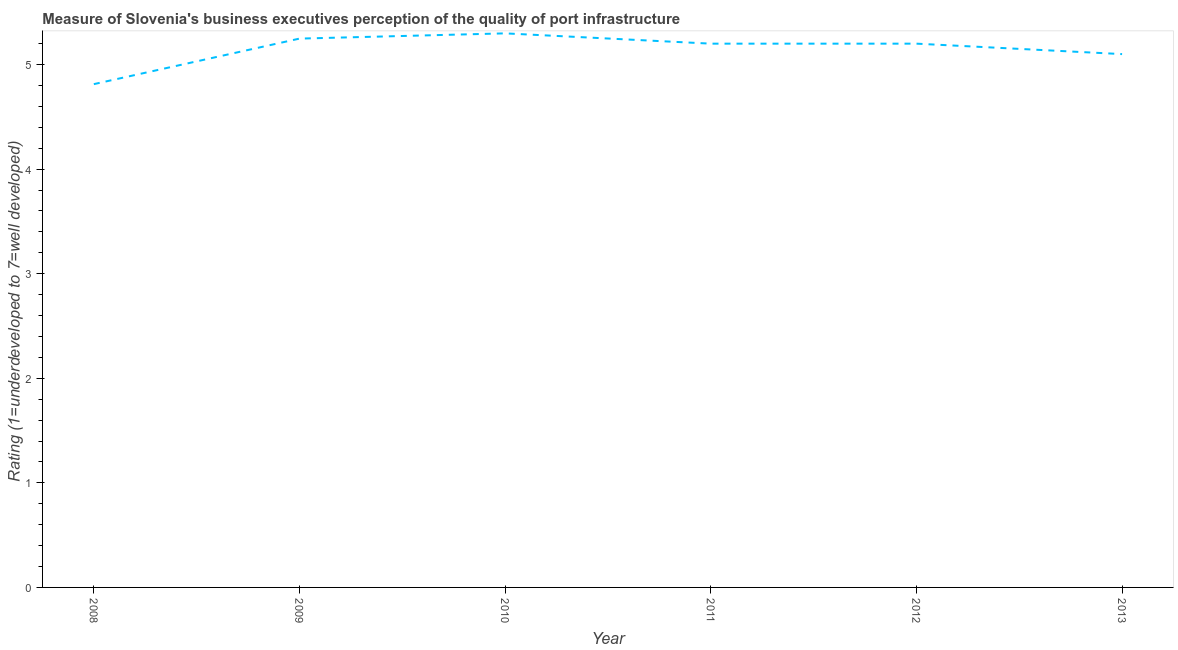What is the rating measuring quality of port infrastructure in 2009?
Give a very brief answer. 5.25. Across all years, what is the maximum rating measuring quality of port infrastructure?
Offer a very short reply. 5.3. Across all years, what is the minimum rating measuring quality of port infrastructure?
Your answer should be compact. 4.81. In which year was the rating measuring quality of port infrastructure maximum?
Your answer should be very brief. 2010. What is the sum of the rating measuring quality of port infrastructure?
Provide a short and direct response. 30.86. What is the difference between the rating measuring quality of port infrastructure in 2008 and 2013?
Ensure brevity in your answer.  -0.29. What is the average rating measuring quality of port infrastructure per year?
Your answer should be very brief. 5.14. What is the median rating measuring quality of port infrastructure?
Provide a short and direct response. 5.2. Do a majority of the years between 2009 and 2008 (inclusive) have rating measuring quality of port infrastructure greater than 2.4 ?
Provide a succinct answer. No. What is the ratio of the rating measuring quality of port infrastructure in 2009 to that in 2013?
Your answer should be compact. 1.03. Is the rating measuring quality of port infrastructure in 2012 less than that in 2013?
Your answer should be very brief. No. What is the difference between the highest and the second highest rating measuring quality of port infrastructure?
Keep it short and to the point. 0.05. Is the sum of the rating measuring quality of port infrastructure in 2010 and 2011 greater than the maximum rating measuring quality of port infrastructure across all years?
Keep it short and to the point. Yes. What is the difference between the highest and the lowest rating measuring quality of port infrastructure?
Provide a succinct answer. 0.49. How many lines are there?
Offer a terse response. 1. What is the difference between two consecutive major ticks on the Y-axis?
Your answer should be compact. 1. Are the values on the major ticks of Y-axis written in scientific E-notation?
Keep it short and to the point. No. Does the graph contain any zero values?
Give a very brief answer. No. Does the graph contain grids?
Provide a short and direct response. No. What is the title of the graph?
Make the answer very short. Measure of Slovenia's business executives perception of the quality of port infrastructure. What is the label or title of the Y-axis?
Offer a very short reply. Rating (1=underdeveloped to 7=well developed) . What is the Rating (1=underdeveloped to 7=well developed)  of 2008?
Provide a short and direct response. 4.81. What is the Rating (1=underdeveloped to 7=well developed)  of 2009?
Keep it short and to the point. 5.25. What is the Rating (1=underdeveloped to 7=well developed)  of 2010?
Ensure brevity in your answer.  5.3. What is the Rating (1=underdeveloped to 7=well developed)  in 2012?
Provide a short and direct response. 5.2. What is the Rating (1=underdeveloped to 7=well developed)  in 2013?
Keep it short and to the point. 5.1. What is the difference between the Rating (1=underdeveloped to 7=well developed)  in 2008 and 2009?
Keep it short and to the point. -0.44. What is the difference between the Rating (1=underdeveloped to 7=well developed)  in 2008 and 2010?
Ensure brevity in your answer.  -0.49. What is the difference between the Rating (1=underdeveloped to 7=well developed)  in 2008 and 2011?
Your response must be concise. -0.39. What is the difference between the Rating (1=underdeveloped to 7=well developed)  in 2008 and 2012?
Make the answer very short. -0.39. What is the difference between the Rating (1=underdeveloped to 7=well developed)  in 2008 and 2013?
Provide a short and direct response. -0.29. What is the difference between the Rating (1=underdeveloped to 7=well developed)  in 2009 and 2010?
Give a very brief answer. -0.05. What is the difference between the Rating (1=underdeveloped to 7=well developed)  in 2009 and 2011?
Make the answer very short. 0.05. What is the difference between the Rating (1=underdeveloped to 7=well developed)  in 2009 and 2012?
Give a very brief answer. 0.05. What is the difference between the Rating (1=underdeveloped to 7=well developed)  in 2009 and 2013?
Your response must be concise. 0.15. What is the difference between the Rating (1=underdeveloped to 7=well developed)  in 2010 and 2011?
Make the answer very short. 0.1. What is the difference between the Rating (1=underdeveloped to 7=well developed)  in 2010 and 2012?
Keep it short and to the point. 0.1. What is the difference between the Rating (1=underdeveloped to 7=well developed)  in 2010 and 2013?
Provide a succinct answer. 0.2. What is the difference between the Rating (1=underdeveloped to 7=well developed)  in 2011 and 2012?
Keep it short and to the point. 0. What is the difference between the Rating (1=underdeveloped to 7=well developed)  in 2012 and 2013?
Provide a succinct answer. 0.1. What is the ratio of the Rating (1=underdeveloped to 7=well developed)  in 2008 to that in 2009?
Give a very brief answer. 0.92. What is the ratio of the Rating (1=underdeveloped to 7=well developed)  in 2008 to that in 2010?
Your answer should be compact. 0.91. What is the ratio of the Rating (1=underdeveloped to 7=well developed)  in 2008 to that in 2011?
Ensure brevity in your answer.  0.93. What is the ratio of the Rating (1=underdeveloped to 7=well developed)  in 2008 to that in 2012?
Your response must be concise. 0.93. What is the ratio of the Rating (1=underdeveloped to 7=well developed)  in 2008 to that in 2013?
Provide a short and direct response. 0.94. What is the ratio of the Rating (1=underdeveloped to 7=well developed)  in 2009 to that in 2012?
Your answer should be compact. 1.01. What is the ratio of the Rating (1=underdeveloped to 7=well developed)  in 2009 to that in 2013?
Keep it short and to the point. 1.03. What is the ratio of the Rating (1=underdeveloped to 7=well developed)  in 2010 to that in 2011?
Ensure brevity in your answer.  1.02. What is the ratio of the Rating (1=underdeveloped to 7=well developed)  in 2010 to that in 2012?
Give a very brief answer. 1.02. What is the ratio of the Rating (1=underdeveloped to 7=well developed)  in 2010 to that in 2013?
Offer a very short reply. 1.04. 